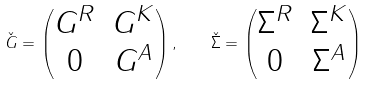<formula> <loc_0><loc_0><loc_500><loc_500>\check { G } = \begin{pmatrix} G ^ { R } & G ^ { K } \\ 0 & G ^ { A } \end{pmatrix} , \quad \check { \Sigma } = \begin{pmatrix} \Sigma ^ { R } & \Sigma ^ { K } \\ 0 & \Sigma ^ { A } \end{pmatrix}</formula> 